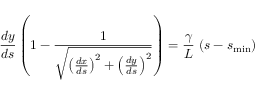Convert formula to latex. <formula><loc_0><loc_0><loc_500><loc_500>\frac { d y } { d s } \left ( 1 - \frac { 1 } { \sqrt { \left ( \frac { d x } { d s } \right ) ^ { 2 } + \left ( \frac { d y } { d s } \right ) ^ { 2 } } } \right ) = \frac { \gamma } { L } \, \left ( s - s _ { \min } \right )</formula> 